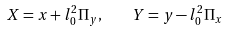Convert formula to latex. <formula><loc_0><loc_0><loc_500><loc_500>X = x + l _ { 0 } ^ { 2 } \Pi _ { y } , \quad Y = y - l _ { 0 } ^ { 2 } \Pi _ { x }</formula> 